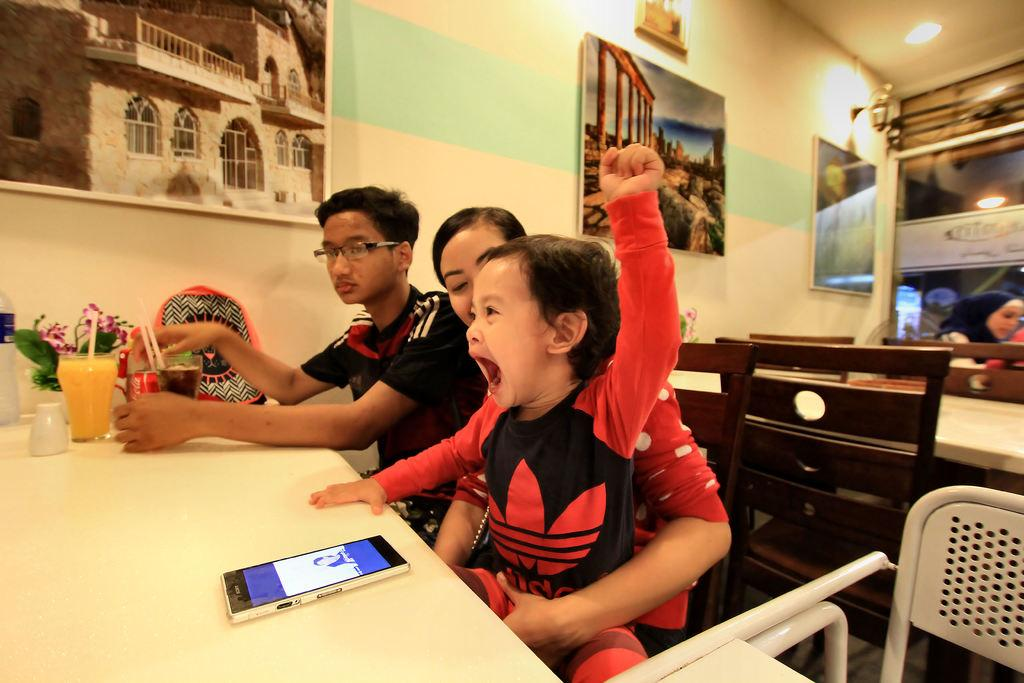How many people are sitting in the image? There are three people sitting on chairs in the image. What objects can be seen on the table in the image? There is a phone, glasses, and a bag on the table in the image. What is hanging on the wall in the image? There are frames on the wall in the image. What type of corn can be seen growing in the window of the image? There is no corn visible in the image, nor is there a window present. 